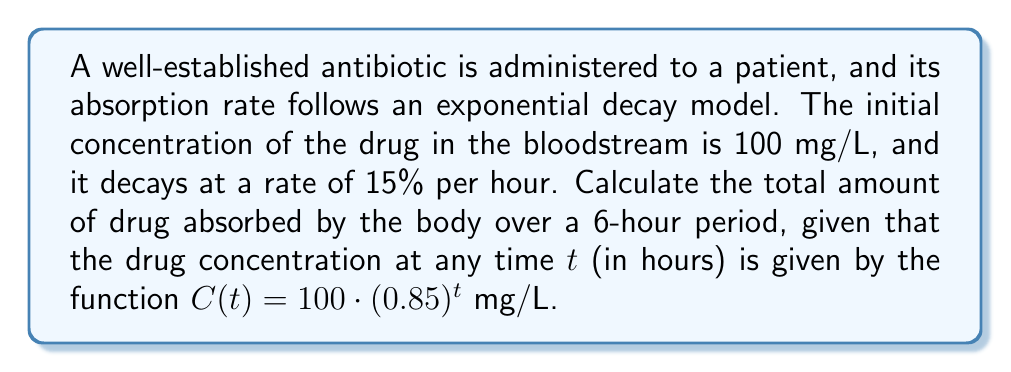Show me your answer to this math problem. To solve this problem, we need to calculate the area under the curve of the drug concentration function over the 6-hour period. This can be done using the definite integral of the exponential function.

Step 1: Set up the definite integral
$$\int_0^6 100 \cdot (0.85)^t dt$$

Step 2: Use the formula for the integral of an exponential function
$$\int a^x dx = \frac{a^x}{\ln(a)} + C$$

In our case, $a = 0.85$ and we need to evaluate from 0 to 6:

$$\left[\frac{100 \cdot (0.85)^t}{\ln(0.85)}\right]_0^6$$

Step 3: Evaluate the integral at the limits
$$\frac{100 \cdot (0.85)^6}{\ln(0.85)} - \frac{100 \cdot (0.85)^0}{\ln(0.85)}$$

Step 4: Simplify
$$\frac{100 \cdot (0.85)^6 - 100}{\ln(0.85)}$$

Step 5: Calculate the result
$$\frac{100 \cdot 0.377628 - 100}{-0.162519} \approx 382.65$$

The units for this result are mg·h/L, which represents the area under the concentration-time curve.

Step 6: Convert to total amount absorbed
Assuming a blood volume of 5 L for an average adult:
$$382.65 \text{ mg·h/L} \cdot 5 \text{ L} = 1913.25 \text{ mg·h}$$
Answer: 1913.25 mg·h 